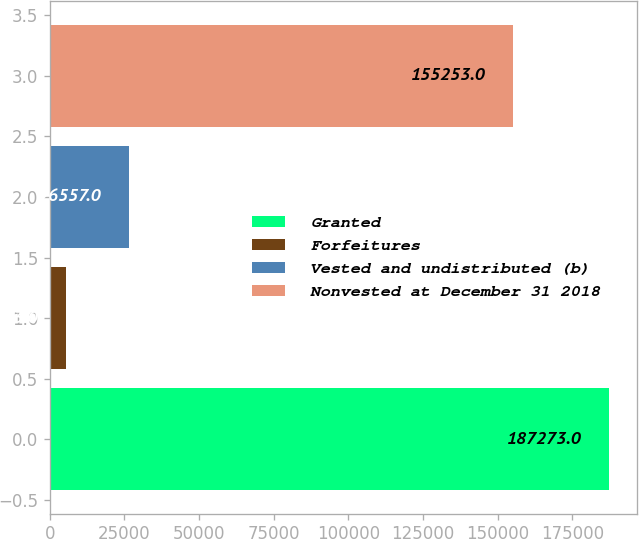Convert chart. <chart><loc_0><loc_0><loc_500><loc_500><bar_chart><fcel>Granted<fcel>Forfeitures<fcel>Vested and undistributed (b)<fcel>Nonvested at December 31 2018<nl><fcel>187273<fcel>5463<fcel>26557<fcel>155253<nl></chart> 